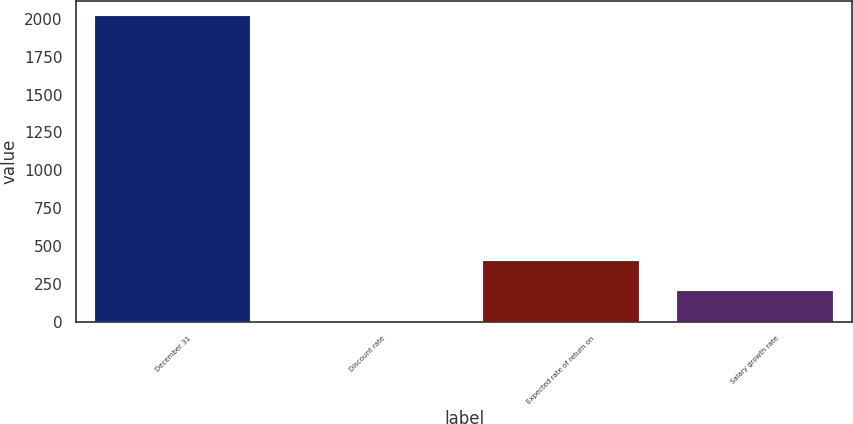Convert chart to OTSL. <chart><loc_0><loc_0><loc_500><loc_500><bar_chart><fcel>December 31<fcel>Discount rate<fcel>Expected rate of return on<fcel>Salary growth rate<nl><fcel>2017<fcel>2.2<fcel>405.16<fcel>203.68<nl></chart> 